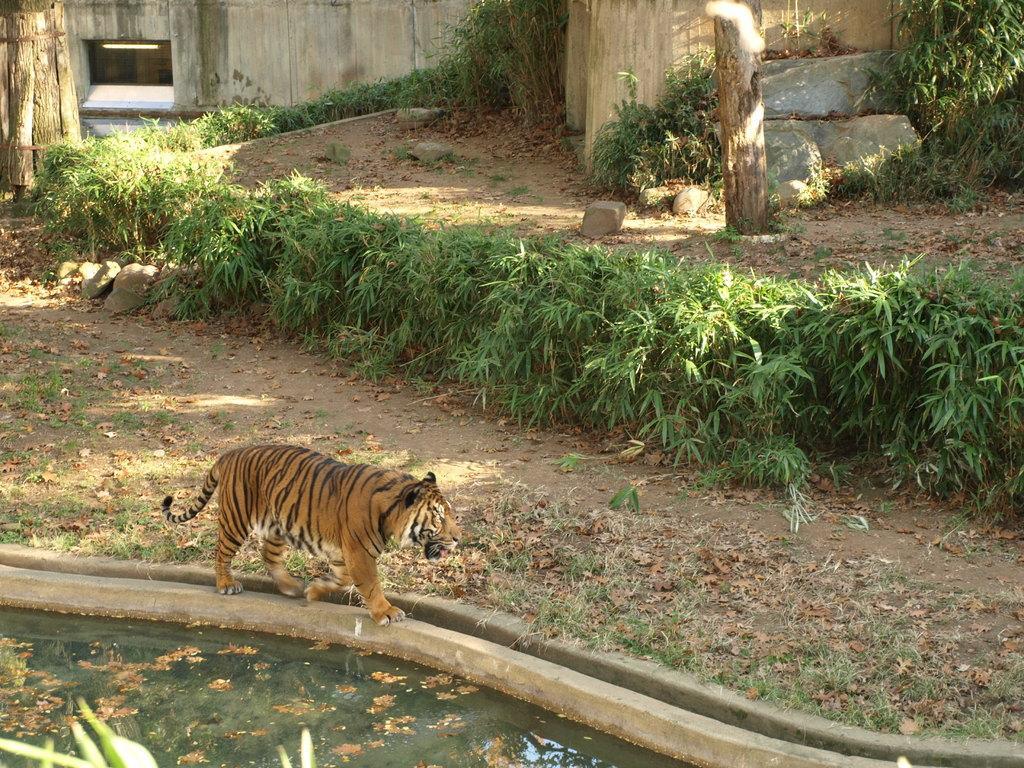In one or two sentences, can you explain what this image depicts? In this picture we can see a tiger walking, water, trees, stones and in the background we can see wall. 